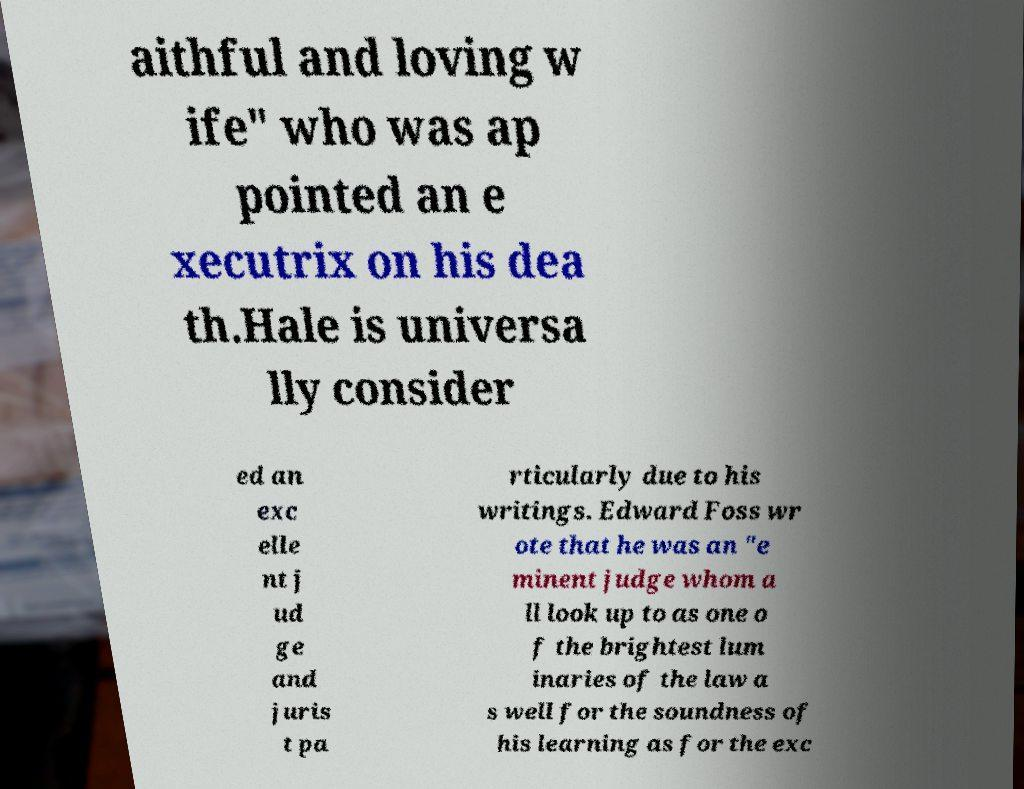Can you accurately transcribe the text from the provided image for me? aithful and loving w ife" who was ap pointed an e xecutrix on his dea th.Hale is universa lly consider ed an exc elle nt j ud ge and juris t pa rticularly due to his writings. Edward Foss wr ote that he was an "e minent judge whom a ll look up to as one o f the brightest lum inaries of the law a s well for the soundness of his learning as for the exc 